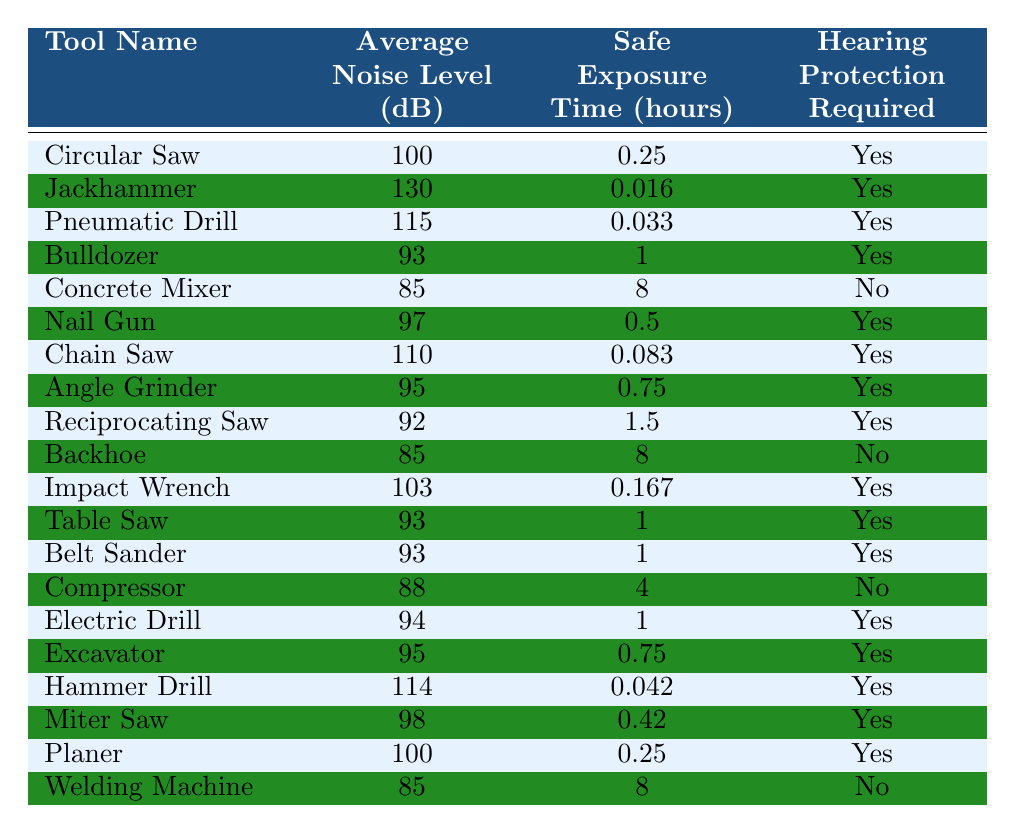What is the average noise level of the nail gun? The table shows the average noise level for the nail gun, which is listed as 97 dB.
Answer: 97 dB Is hearing protection required for using a concrete mixer? According to the table, under "Hearing Protection Required," the concrete mixer is marked as "No."
Answer: No How many tools have a safe exposure time of less than 1 hour? Counting the tools with a safe exposure time of less than 1 hour: Jackhammer (0.016), Pneumatic Drill (0.033), Chain Saw (0.083), Hammer Drill (0.042), and Impact Wrench (0.167) gives a total of 5 tools.
Answer: 5 tools What is the average safe exposure time for tools that do require hearing protection? First, identify the tools that require hearing protection: Circular Saw (0.25), Jackhammer (0.016), Pneumatic Drill (0.033), Nail Gun (0.5), Chain Saw (0.083), Angle Grinder (0.75), Impact Wrench (0.167), Electric Drill (1), Hammer Drill (0.042), Miter Saw (0.42), Planer (0.25) – this totals 11 tools. The sum of their exposure times is approximately 3.658 hours. Therefore, the average is 3.658/11 ≈ 0.333 hours.
Answer: 0.333 hours What tool has the highest noise level and how much is it? The Jackhammer has the highest noise level listed in the table at 130 dB.
Answer: 130 dB How many tools have noise levels below 90 dB? The tools below 90 dB are the Concrete Mixer (85), Backhoe (85), and Compressor (88). There are 3 tools altogether that meet this criterion.
Answer: 3 tools Is it safe to use a backhoe for more than 8 hours without hearing protection? The table shows that the backhoe has a safe exposure time of 8 hours and indicates that hearing protection is not required. Therefore, it is safe to use for that duration.
Answer: Yes What is the difference in noise level between the circular saw and the impact wrench? The circular saw has a noise level of 100 dB, while the impact wrench has a noise level of 103 dB. The difference is 103 - 100 = 3 dB.
Answer: 3 dB Which tool has a safe exposure time of 1.5 hours and requires hearing protection? The reciprocating saw has a safe exposure time of 1.5 hours and requires hearing protection, as per the table.
Answer: Reciprocating Saw How does the safe exposure time of the miter saw compare to that of the angle grinder? The miter saw has a safe exposure time of 0.42 hours, while the angle grinder has 0.75 hours. Since 0.75 is greater than 0.42, the angle grinder offers a longer safe exposure time.
Answer: Angle Grinder has longer exposure time 